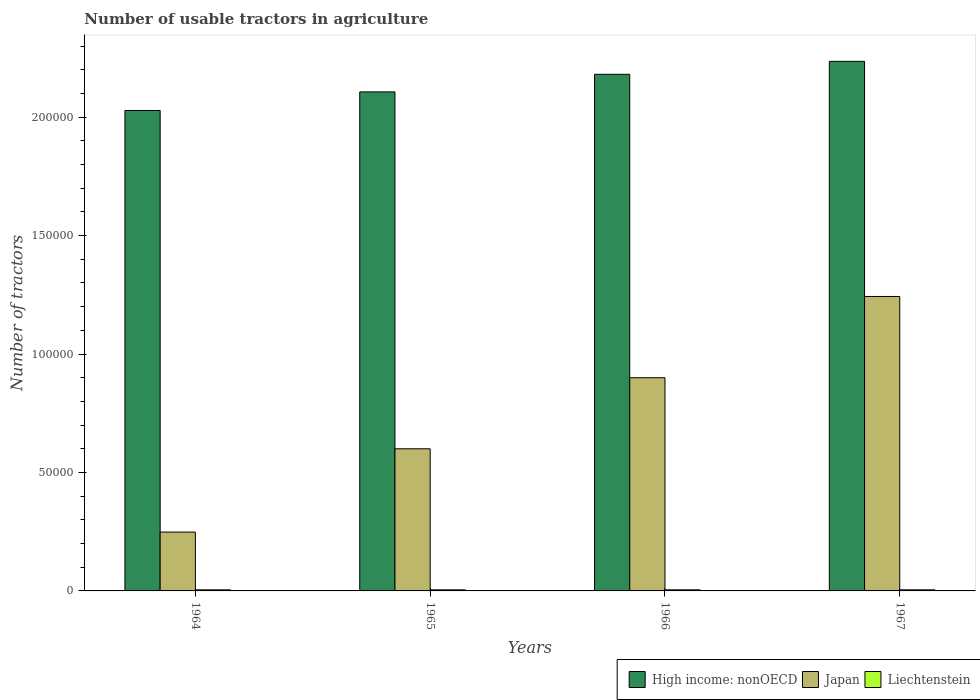How many different coloured bars are there?
Offer a very short reply. 3. How many groups of bars are there?
Give a very brief answer. 4. Are the number of bars per tick equal to the number of legend labels?
Your answer should be very brief. Yes. Are the number of bars on each tick of the X-axis equal?
Ensure brevity in your answer.  Yes. How many bars are there on the 4th tick from the left?
Give a very brief answer. 3. What is the label of the 3rd group of bars from the left?
Offer a terse response. 1966. What is the number of usable tractors in agriculture in High income: nonOECD in 1967?
Offer a very short reply. 2.24e+05. Across all years, what is the maximum number of usable tractors in agriculture in Liechtenstein?
Provide a short and direct response. 463. Across all years, what is the minimum number of usable tractors in agriculture in Japan?
Your answer should be compact. 2.48e+04. In which year was the number of usable tractors in agriculture in Japan maximum?
Give a very brief answer. 1967. In which year was the number of usable tractors in agriculture in Liechtenstein minimum?
Offer a very short reply. 1964. What is the total number of usable tractors in agriculture in Japan in the graph?
Give a very brief answer. 2.99e+05. What is the difference between the number of usable tractors in agriculture in High income: nonOECD in 1964 and that in 1966?
Your answer should be compact. -1.53e+04. What is the difference between the number of usable tractors in agriculture in Japan in 1965 and the number of usable tractors in agriculture in Liechtenstein in 1967?
Your answer should be very brief. 5.95e+04. What is the average number of usable tractors in agriculture in High income: nonOECD per year?
Ensure brevity in your answer.  2.14e+05. In the year 1965, what is the difference between the number of usable tractors in agriculture in Liechtenstein and number of usable tractors in agriculture in Japan?
Keep it short and to the point. -5.95e+04. What is the ratio of the number of usable tractors in agriculture in Liechtenstein in 1966 to that in 1967?
Ensure brevity in your answer.  0.99. What is the difference between the highest and the second highest number of usable tractors in agriculture in High income: nonOECD?
Your response must be concise. 5467. What is the difference between the highest and the lowest number of usable tractors in agriculture in Japan?
Offer a very short reply. 9.95e+04. In how many years, is the number of usable tractors in agriculture in High income: nonOECD greater than the average number of usable tractors in agriculture in High income: nonOECD taken over all years?
Provide a succinct answer. 2. What does the 3rd bar from the left in 1965 represents?
Give a very brief answer. Liechtenstein. What does the 2nd bar from the right in 1967 represents?
Your response must be concise. Japan. Is it the case that in every year, the sum of the number of usable tractors in agriculture in Liechtenstein and number of usable tractors in agriculture in High income: nonOECD is greater than the number of usable tractors in agriculture in Japan?
Your answer should be compact. Yes. What is the difference between two consecutive major ticks on the Y-axis?
Your answer should be compact. 5.00e+04. Does the graph contain any zero values?
Your answer should be compact. No. Does the graph contain grids?
Offer a very short reply. No. How many legend labels are there?
Make the answer very short. 3. What is the title of the graph?
Make the answer very short. Number of usable tractors in agriculture. What is the label or title of the X-axis?
Offer a very short reply. Years. What is the label or title of the Y-axis?
Your response must be concise. Number of tractors. What is the Number of tractors in High income: nonOECD in 1964?
Ensure brevity in your answer.  2.03e+05. What is the Number of tractors of Japan in 1964?
Keep it short and to the point. 2.48e+04. What is the Number of tractors of Liechtenstein in 1964?
Offer a very short reply. 455. What is the Number of tractors in High income: nonOECD in 1965?
Provide a short and direct response. 2.11e+05. What is the Number of tractors in Liechtenstein in 1965?
Ensure brevity in your answer.  457. What is the Number of tractors in High income: nonOECD in 1966?
Make the answer very short. 2.18e+05. What is the Number of tractors in Japan in 1966?
Ensure brevity in your answer.  9.00e+04. What is the Number of tractors in Liechtenstein in 1966?
Give a very brief answer. 460. What is the Number of tractors of High income: nonOECD in 1967?
Your answer should be compact. 2.24e+05. What is the Number of tractors of Japan in 1967?
Your response must be concise. 1.24e+05. What is the Number of tractors in Liechtenstein in 1967?
Ensure brevity in your answer.  463. Across all years, what is the maximum Number of tractors of High income: nonOECD?
Make the answer very short. 2.24e+05. Across all years, what is the maximum Number of tractors in Japan?
Your answer should be compact. 1.24e+05. Across all years, what is the maximum Number of tractors in Liechtenstein?
Your answer should be compact. 463. Across all years, what is the minimum Number of tractors of High income: nonOECD?
Keep it short and to the point. 2.03e+05. Across all years, what is the minimum Number of tractors in Japan?
Offer a very short reply. 2.48e+04. Across all years, what is the minimum Number of tractors in Liechtenstein?
Your answer should be very brief. 455. What is the total Number of tractors in High income: nonOECD in the graph?
Make the answer very short. 8.55e+05. What is the total Number of tractors in Japan in the graph?
Your response must be concise. 2.99e+05. What is the total Number of tractors in Liechtenstein in the graph?
Offer a terse response. 1835. What is the difference between the Number of tractors of High income: nonOECD in 1964 and that in 1965?
Provide a succinct answer. -7840. What is the difference between the Number of tractors in Japan in 1964 and that in 1965?
Your response must be concise. -3.52e+04. What is the difference between the Number of tractors of High income: nonOECD in 1964 and that in 1966?
Your response must be concise. -1.53e+04. What is the difference between the Number of tractors of Japan in 1964 and that in 1966?
Keep it short and to the point. -6.52e+04. What is the difference between the Number of tractors of High income: nonOECD in 1964 and that in 1967?
Your answer should be compact. -2.07e+04. What is the difference between the Number of tractors of Japan in 1964 and that in 1967?
Your answer should be very brief. -9.95e+04. What is the difference between the Number of tractors of Liechtenstein in 1964 and that in 1967?
Make the answer very short. -8. What is the difference between the Number of tractors of High income: nonOECD in 1965 and that in 1966?
Make the answer very short. -7426. What is the difference between the Number of tractors in Liechtenstein in 1965 and that in 1966?
Provide a short and direct response. -3. What is the difference between the Number of tractors of High income: nonOECD in 1965 and that in 1967?
Offer a terse response. -1.29e+04. What is the difference between the Number of tractors in Japan in 1965 and that in 1967?
Offer a very short reply. -6.43e+04. What is the difference between the Number of tractors of High income: nonOECD in 1966 and that in 1967?
Provide a succinct answer. -5467. What is the difference between the Number of tractors in Japan in 1966 and that in 1967?
Your answer should be compact. -3.43e+04. What is the difference between the Number of tractors in Liechtenstein in 1966 and that in 1967?
Make the answer very short. -3. What is the difference between the Number of tractors in High income: nonOECD in 1964 and the Number of tractors in Japan in 1965?
Provide a short and direct response. 1.43e+05. What is the difference between the Number of tractors of High income: nonOECD in 1964 and the Number of tractors of Liechtenstein in 1965?
Ensure brevity in your answer.  2.02e+05. What is the difference between the Number of tractors of Japan in 1964 and the Number of tractors of Liechtenstein in 1965?
Give a very brief answer. 2.44e+04. What is the difference between the Number of tractors of High income: nonOECD in 1964 and the Number of tractors of Japan in 1966?
Give a very brief answer. 1.13e+05. What is the difference between the Number of tractors in High income: nonOECD in 1964 and the Number of tractors in Liechtenstein in 1966?
Keep it short and to the point. 2.02e+05. What is the difference between the Number of tractors in Japan in 1964 and the Number of tractors in Liechtenstein in 1966?
Your response must be concise. 2.44e+04. What is the difference between the Number of tractors in High income: nonOECD in 1964 and the Number of tractors in Japan in 1967?
Offer a terse response. 7.85e+04. What is the difference between the Number of tractors of High income: nonOECD in 1964 and the Number of tractors of Liechtenstein in 1967?
Your answer should be very brief. 2.02e+05. What is the difference between the Number of tractors in Japan in 1964 and the Number of tractors in Liechtenstein in 1967?
Make the answer very short. 2.44e+04. What is the difference between the Number of tractors of High income: nonOECD in 1965 and the Number of tractors of Japan in 1966?
Make the answer very short. 1.21e+05. What is the difference between the Number of tractors of High income: nonOECD in 1965 and the Number of tractors of Liechtenstein in 1966?
Give a very brief answer. 2.10e+05. What is the difference between the Number of tractors in Japan in 1965 and the Number of tractors in Liechtenstein in 1966?
Your answer should be very brief. 5.95e+04. What is the difference between the Number of tractors of High income: nonOECD in 1965 and the Number of tractors of Japan in 1967?
Ensure brevity in your answer.  8.64e+04. What is the difference between the Number of tractors in High income: nonOECD in 1965 and the Number of tractors in Liechtenstein in 1967?
Your answer should be very brief. 2.10e+05. What is the difference between the Number of tractors in Japan in 1965 and the Number of tractors in Liechtenstein in 1967?
Your answer should be very brief. 5.95e+04. What is the difference between the Number of tractors in High income: nonOECD in 1966 and the Number of tractors in Japan in 1967?
Ensure brevity in your answer.  9.38e+04. What is the difference between the Number of tractors in High income: nonOECD in 1966 and the Number of tractors in Liechtenstein in 1967?
Offer a terse response. 2.18e+05. What is the difference between the Number of tractors in Japan in 1966 and the Number of tractors in Liechtenstein in 1967?
Keep it short and to the point. 8.95e+04. What is the average Number of tractors in High income: nonOECD per year?
Offer a terse response. 2.14e+05. What is the average Number of tractors of Japan per year?
Offer a terse response. 7.48e+04. What is the average Number of tractors of Liechtenstein per year?
Your answer should be compact. 458.75. In the year 1964, what is the difference between the Number of tractors in High income: nonOECD and Number of tractors in Japan?
Provide a succinct answer. 1.78e+05. In the year 1964, what is the difference between the Number of tractors of High income: nonOECD and Number of tractors of Liechtenstein?
Give a very brief answer. 2.02e+05. In the year 1964, what is the difference between the Number of tractors of Japan and Number of tractors of Liechtenstein?
Ensure brevity in your answer.  2.44e+04. In the year 1965, what is the difference between the Number of tractors in High income: nonOECD and Number of tractors in Japan?
Ensure brevity in your answer.  1.51e+05. In the year 1965, what is the difference between the Number of tractors in High income: nonOECD and Number of tractors in Liechtenstein?
Your answer should be very brief. 2.10e+05. In the year 1965, what is the difference between the Number of tractors of Japan and Number of tractors of Liechtenstein?
Offer a terse response. 5.95e+04. In the year 1966, what is the difference between the Number of tractors in High income: nonOECD and Number of tractors in Japan?
Your answer should be compact. 1.28e+05. In the year 1966, what is the difference between the Number of tractors in High income: nonOECD and Number of tractors in Liechtenstein?
Your answer should be compact. 2.18e+05. In the year 1966, what is the difference between the Number of tractors of Japan and Number of tractors of Liechtenstein?
Provide a succinct answer. 8.95e+04. In the year 1967, what is the difference between the Number of tractors of High income: nonOECD and Number of tractors of Japan?
Provide a succinct answer. 9.93e+04. In the year 1967, what is the difference between the Number of tractors in High income: nonOECD and Number of tractors in Liechtenstein?
Offer a very short reply. 2.23e+05. In the year 1967, what is the difference between the Number of tractors of Japan and Number of tractors of Liechtenstein?
Your answer should be very brief. 1.24e+05. What is the ratio of the Number of tractors of High income: nonOECD in 1964 to that in 1965?
Your answer should be compact. 0.96. What is the ratio of the Number of tractors in Japan in 1964 to that in 1965?
Your response must be concise. 0.41. What is the ratio of the Number of tractors of High income: nonOECD in 1964 to that in 1966?
Offer a terse response. 0.93. What is the ratio of the Number of tractors in Japan in 1964 to that in 1966?
Your response must be concise. 0.28. What is the ratio of the Number of tractors in Liechtenstein in 1964 to that in 1966?
Offer a terse response. 0.99. What is the ratio of the Number of tractors of High income: nonOECD in 1964 to that in 1967?
Your answer should be very brief. 0.91. What is the ratio of the Number of tractors in Japan in 1964 to that in 1967?
Ensure brevity in your answer.  0.2. What is the ratio of the Number of tractors in Liechtenstein in 1964 to that in 1967?
Keep it short and to the point. 0.98. What is the ratio of the Number of tractors in High income: nonOECD in 1965 to that in 1966?
Make the answer very short. 0.97. What is the ratio of the Number of tractors in Japan in 1965 to that in 1966?
Your response must be concise. 0.67. What is the ratio of the Number of tractors of Liechtenstein in 1965 to that in 1966?
Offer a terse response. 0.99. What is the ratio of the Number of tractors of High income: nonOECD in 1965 to that in 1967?
Offer a terse response. 0.94. What is the ratio of the Number of tractors in Japan in 1965 to that in 1967?
Keep it short and to the point. 0.48. What is the ratio of the Number of tractors of High income: nonOECD in 1966 to that in 1967?
Provide a succinct answer. 0.98. What is the ratio of the Number of tractors in Japan in 1966 to that in 1967?
Provide a succinct answer. 0.72. What is the ratio of the Number of tractors in Liechtenstein in 1966 to that in 1967?
Your answer should be very brief. 0.99. What is the difference between the highest and the second highest Number of tractors in High income: nonOECD?
Make the answer very short. 5467. What is the difference between the highest and the second highest Number of tractors of Japan?
Provide a short and direct response. 3.43e+04. What is the difference between the highest and the second highest Number of tractors of Liechtenstein?
Provide a short and direct response. 3. What is the difference between the highest and the lowest Number of tractors in High income: nonOECD?
Your answer should be compact. 2.07e+04. What is the difference between the highest and the lowest Number of tractors in Japan?
Your answer should be compact. 9.95e+04. 